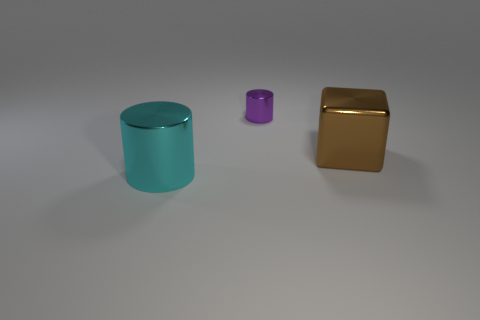What size is the other object that is the same shape as the cyan shiny object? The smaller object appears to be a scaled-down version of the cyan cylinder, maintaining the same proportions but at a reduced size. 